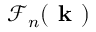Convert formula to latex. <formula><loc_0><loc_0><loc_500><loc_500>\mathcal { F } _ { n } ( k )</formula> 